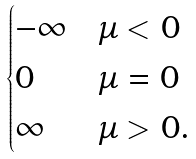Convert formula to latex. <formula><loc_0><loc_0><loc_500><loc_500>\begin{cases} - \infty & \mu < 0 \\ 0 & \mu = 0 \\ \infty & \mu > 0 . \end{cases}</formula> 